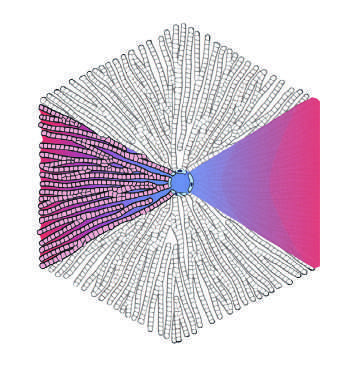where is the terminal hepatic vein in the lobular model?
Answer the question using a single word or phrase. At the center of the lobule 